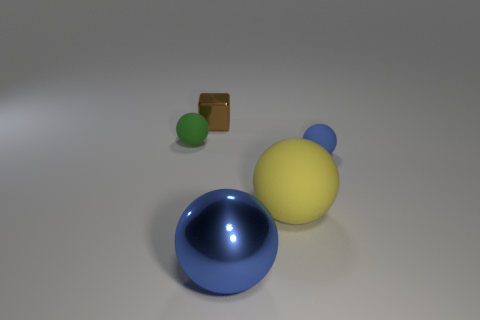How many blue things are either large shiny things or big metallic blocks?
Your answer should be compact. 1. There is another yellow ball that is the same size as the shiny ball; what material is it?
Offer a terse response. Rubber. The tiny object that is both right of the green ball and to the left of the tiny blue rubber ball has what shape?
Ensure brevity in your answer.  Cube. There is a shiny ball that is the same size as the yellow rubber thing; what is its color?
Provide a succinct answer. Blue. Is the size of the blue sphere that is to the left of the small blue sphere the same as the blue sphere that is to the right of the yellow rubber object?
Keep it short and to the point. No. What size is the matte sphere in front of the tiny ball that is right of the metal ball that is to the left of the large yellow matte object?
Give a very brief answer. Large. What is the shape of the blue object that is in front of the rubber ball to the right of the yellow matte ball?
Your response must be concise. Sphere. Is the color of the small rubber ball to the right of the tiny brown thing the same as the metal block?
Offer a very short reply. No. What is the color of the ball that is both on the left side of the big yellow object and behind the blue metallic thing?
Your response must be concise. Green. Are there any red cylinders that have the same material as the tiny green ball?
Give a very brief answer. No. 